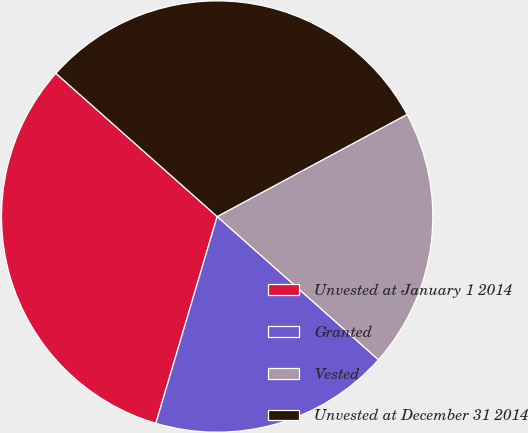Convert chart to OTSL. <chart><loc_0><loc_0><loc_500><loc_500><pie_chart><fcel>Unvested at January 1 2014<fcel>Granted<fcel>Vested<fcel>Unvested at December 31 2014<nl><fcel>31.97%<fcel>18.03%<fcel>19.41%<fcel>30.59%<nl></chart> 